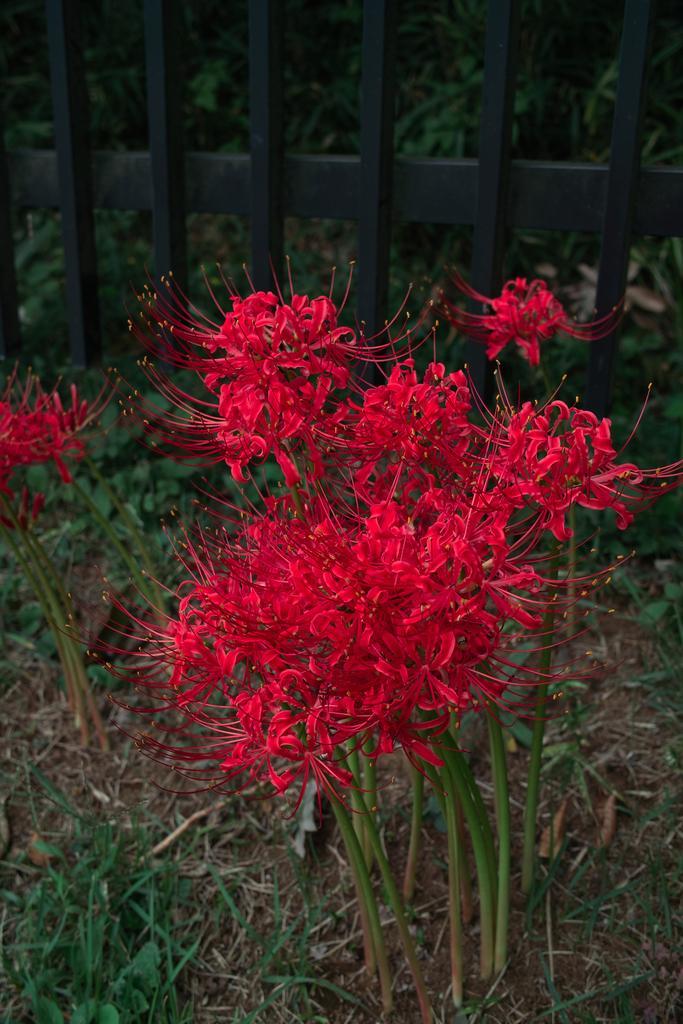How would you summarize this image in a sentence or two? In the background we can see a black grill and plants. Here we can see red flower plants and grass. 